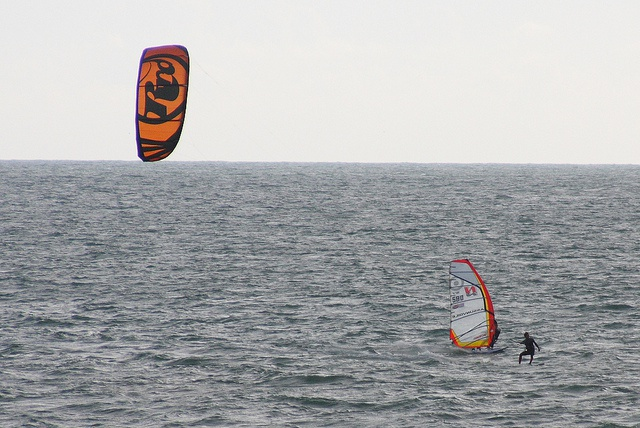Describe the objects in this image and their specific colors. I can see kite in white, black, red, maroon, and brown tones, people in white, black, gray, and darkgray tones, people in white, black, gray, darkgray, and maroon tones, surfboard in white, gray, black, and darkgray tones, and surfboard in white, gray, darkgray, and black tones in this image. 